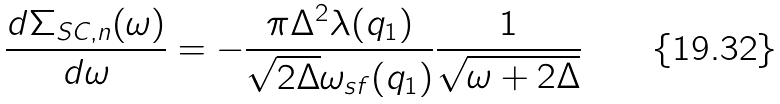<formula> <loc_0><loc_0><loc_500><loc_500>\frac { d \Sigma _ { S C , n } ( \omega ) } { d \omega } = - \frac { \pi \Delta ^ { 2 } \lambda ( { q } _ { 1 } ) } { \sqrt { 2 \Delta } \omega _ { s f } ( { q } _ { 1 } ) } \frac { 1 } { \sqrt { \omega + 2 \Delta } }</formula> 